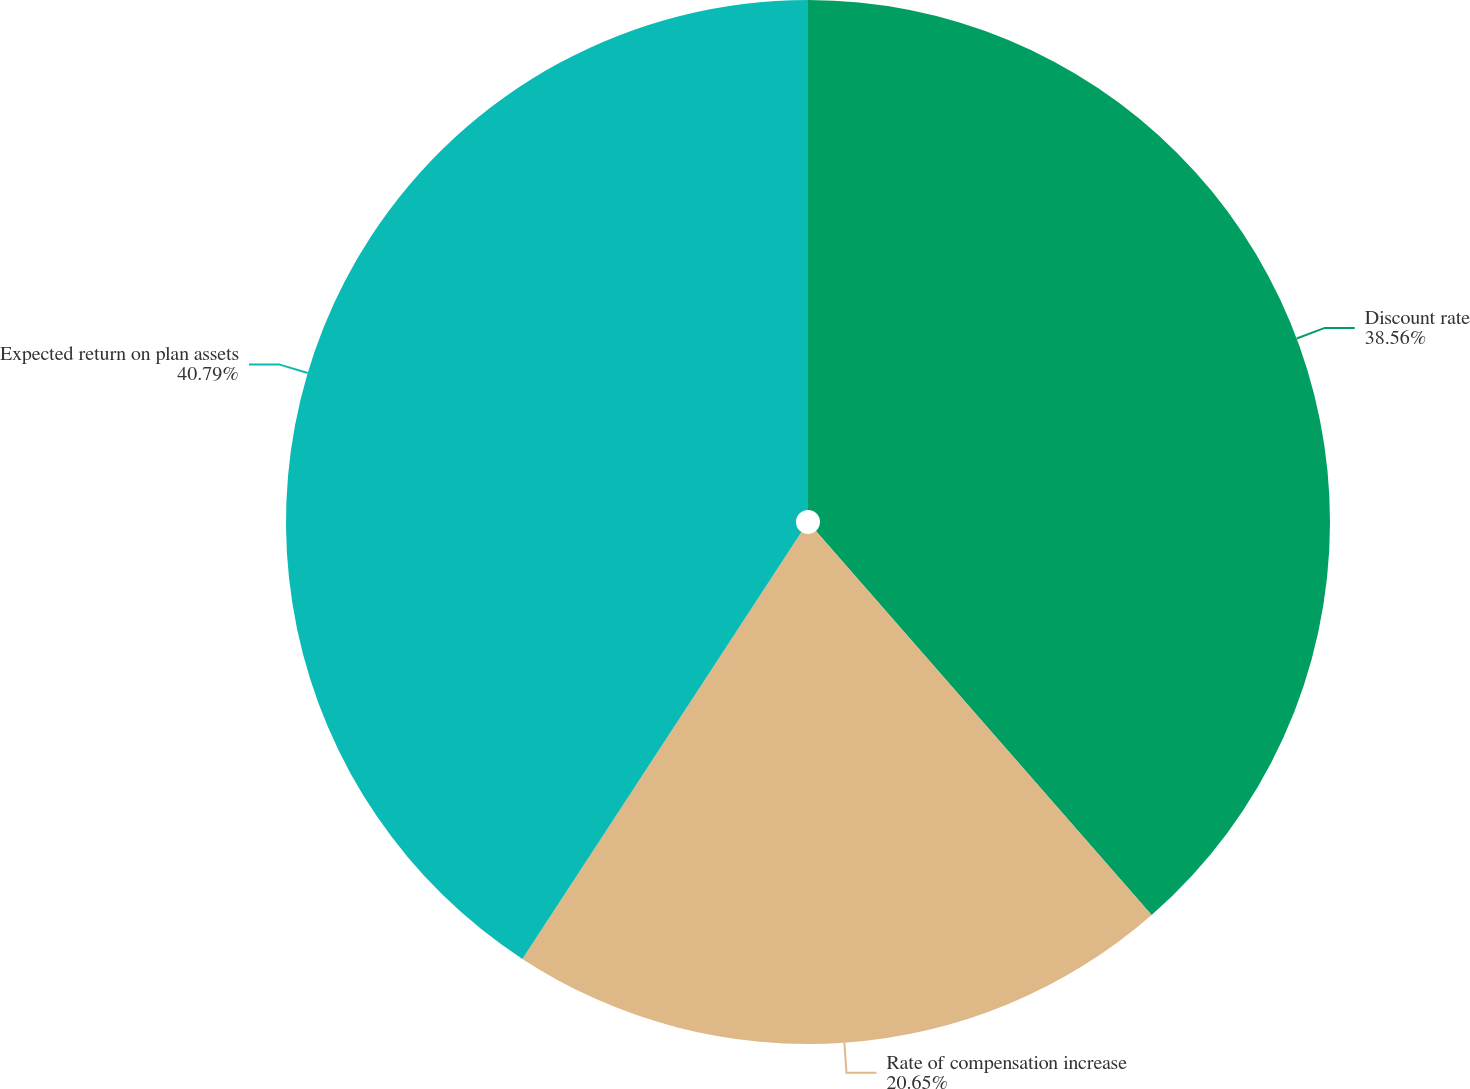<chart> <loc_0><loc_0><loc_500><loc_500><pie_chart><fcel>Discount rate<fcel>Rate of compensation increase<fcel>Expected return on plan assets<nl><fcel>38.56%<fcel>20.65%<fcel>40.78%<nl></chart> 